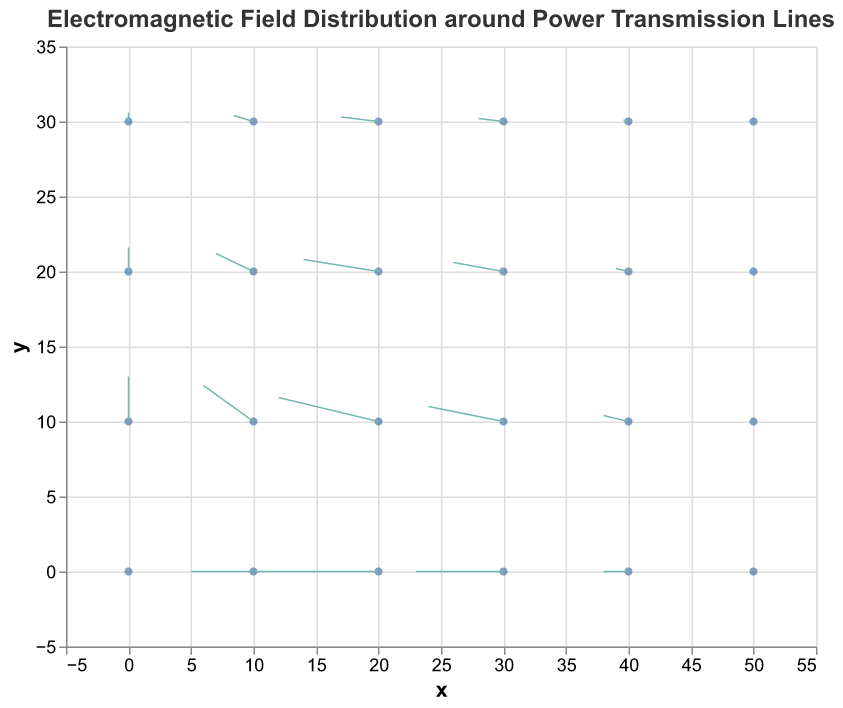What is the title of the figure? The title is usually displayed at the top of the figure and provides a brief description of the plot. In this case, the title reads "Electromagnetic Field Distribution around Power Transmission Lines".
Answer: Electromagnetic Field Distribution around Power Transmission Lines How many data points are plotted in the figure? The data includes multiple (x, y) coordinates each with corresponding electric field components (Ex, Ey). There are 24 such data points from the given data.
Answer: 24 What do the arrows in the quiver plot represent? In a quiver plot, each arrow represents a vector, indicating the direction and magnitude of electric field components at each point. The base of each arrow is assigned to the (x, y) coordinates, and the arrow's direction and length are dictated by the (Ex, Ey) values.
Answer: Electric field vectors At which (x, y) coordinates is the electric field vector (Ex, Ey) largest in magnitude? To find the largest vector, we need to calculate the magnitudes using the formula √(Ex^2 + Ey^2) for each data point. After computing all magnitudes, the largest is found at (20, 0) with Ex = -5 and Ey = 0, leading to a magnitude of 5.
Answer: (20, 0) How does the strength of the electric field change along the y = 0 line? Observing the values along the y = 0 row: at x = 0, 10, 20, 30, 40, and 50, the Ex values are 0, -2.5, -5, -3.5, -1, 0, respectively. Ey is 0 for all these points. The field strength peaks at x = 20 before decreasing again.
Answer: Peaks at x = 20 How does the vector direction change from x = 0 to x = 50 for y = 10? Observing the electric field vectors (Ex, Ey) along the y = 10 line: (0, 1.5), (-2, 1.2), (-4, 0.8), (-3, 0.5), (-1, 0.2), (0, 0), the direction generally trends leftward and downward as x increases.
Answer: Leftward and downward Compare the electric field vector at (10, 10) and (30, 20). Which one has a greater vertical component, and by how much? At (10, 10), the Ey component is 1.2. At (30, 20), the Ey component is 0.3. The difference between these components is 1.2 - 0.3 = 0.9.
Answer: (10, 10) by 0.9 What can you infer about the distribution of electric field vectors along x = 0 as y increases from 0 to 30? Looking at the points (0, y) where y = 0, 10, 20, 30, the Ex component is always 0, but Ey changes from 0 to 1.5, 0.8, and 0.3, respectively. This indicates that the vertical component of the electric field decreases as y increases.
Answer: Vertical component decreases What is the overall trend of the electric field vectors along the x-axis and y-axis in the plot? The electric field vectors show significant horizontal components (Ex) when y = 0 and decreasing Ex values with increased y values. Ey components dominate vertically near y = 10 and diminish as y increases further.
Answer: Dominant horizontal at y=0, dominant vertical at y=10 